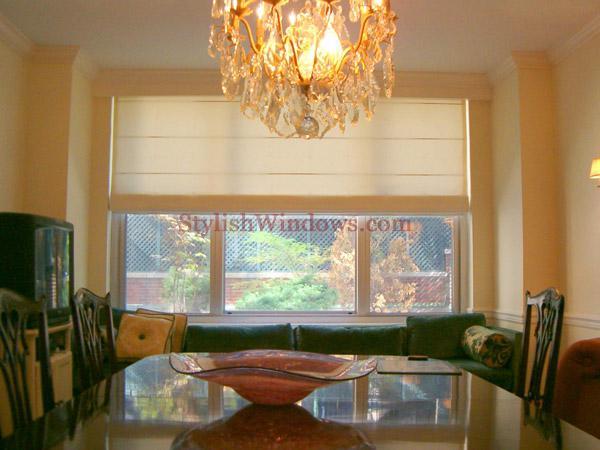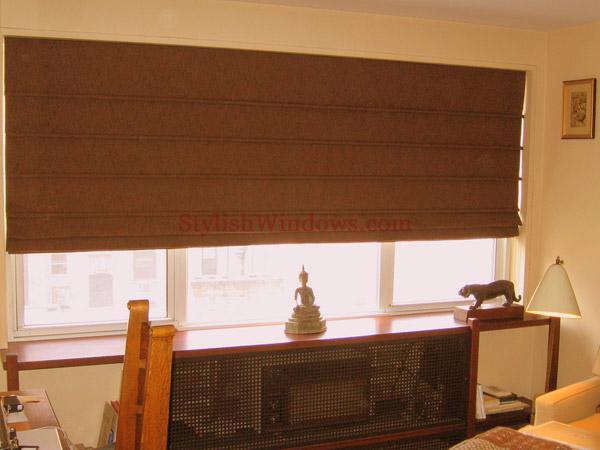The first image is the image on the left, the second image is the image on the right. Evaluate the accuracy of this statement regarding the images: "The right image features windows covered by at least one dark brown shade.". Is it true? Answer yes or no. Yes. The first image is the image on the left, the second image is the image on the right. Examine the images to the left and right. Is the description "The left and right image contains the same number of windows." accurate? Answer yes or no. Yes. 